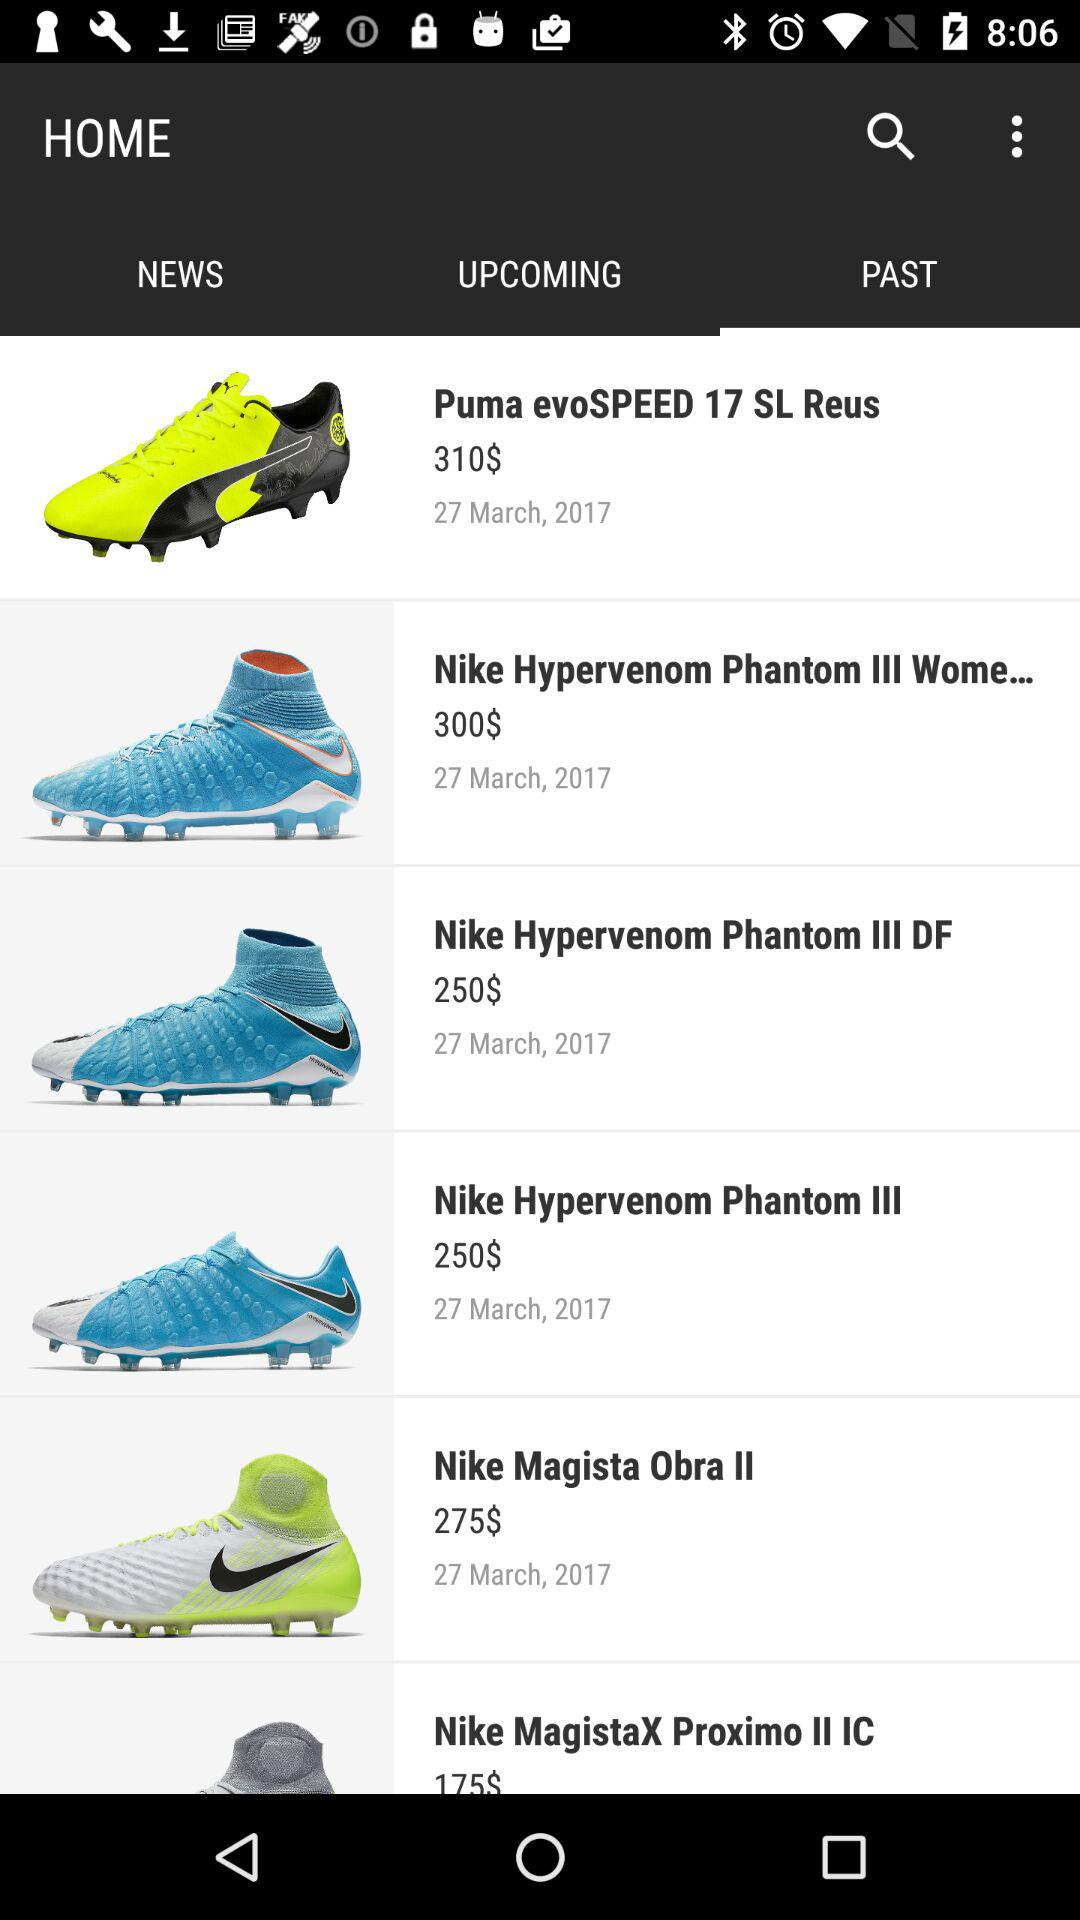How much more expensive is the most expensive shoe than the least expensive shoe?
Answer the question using a single word or phrase. 135 